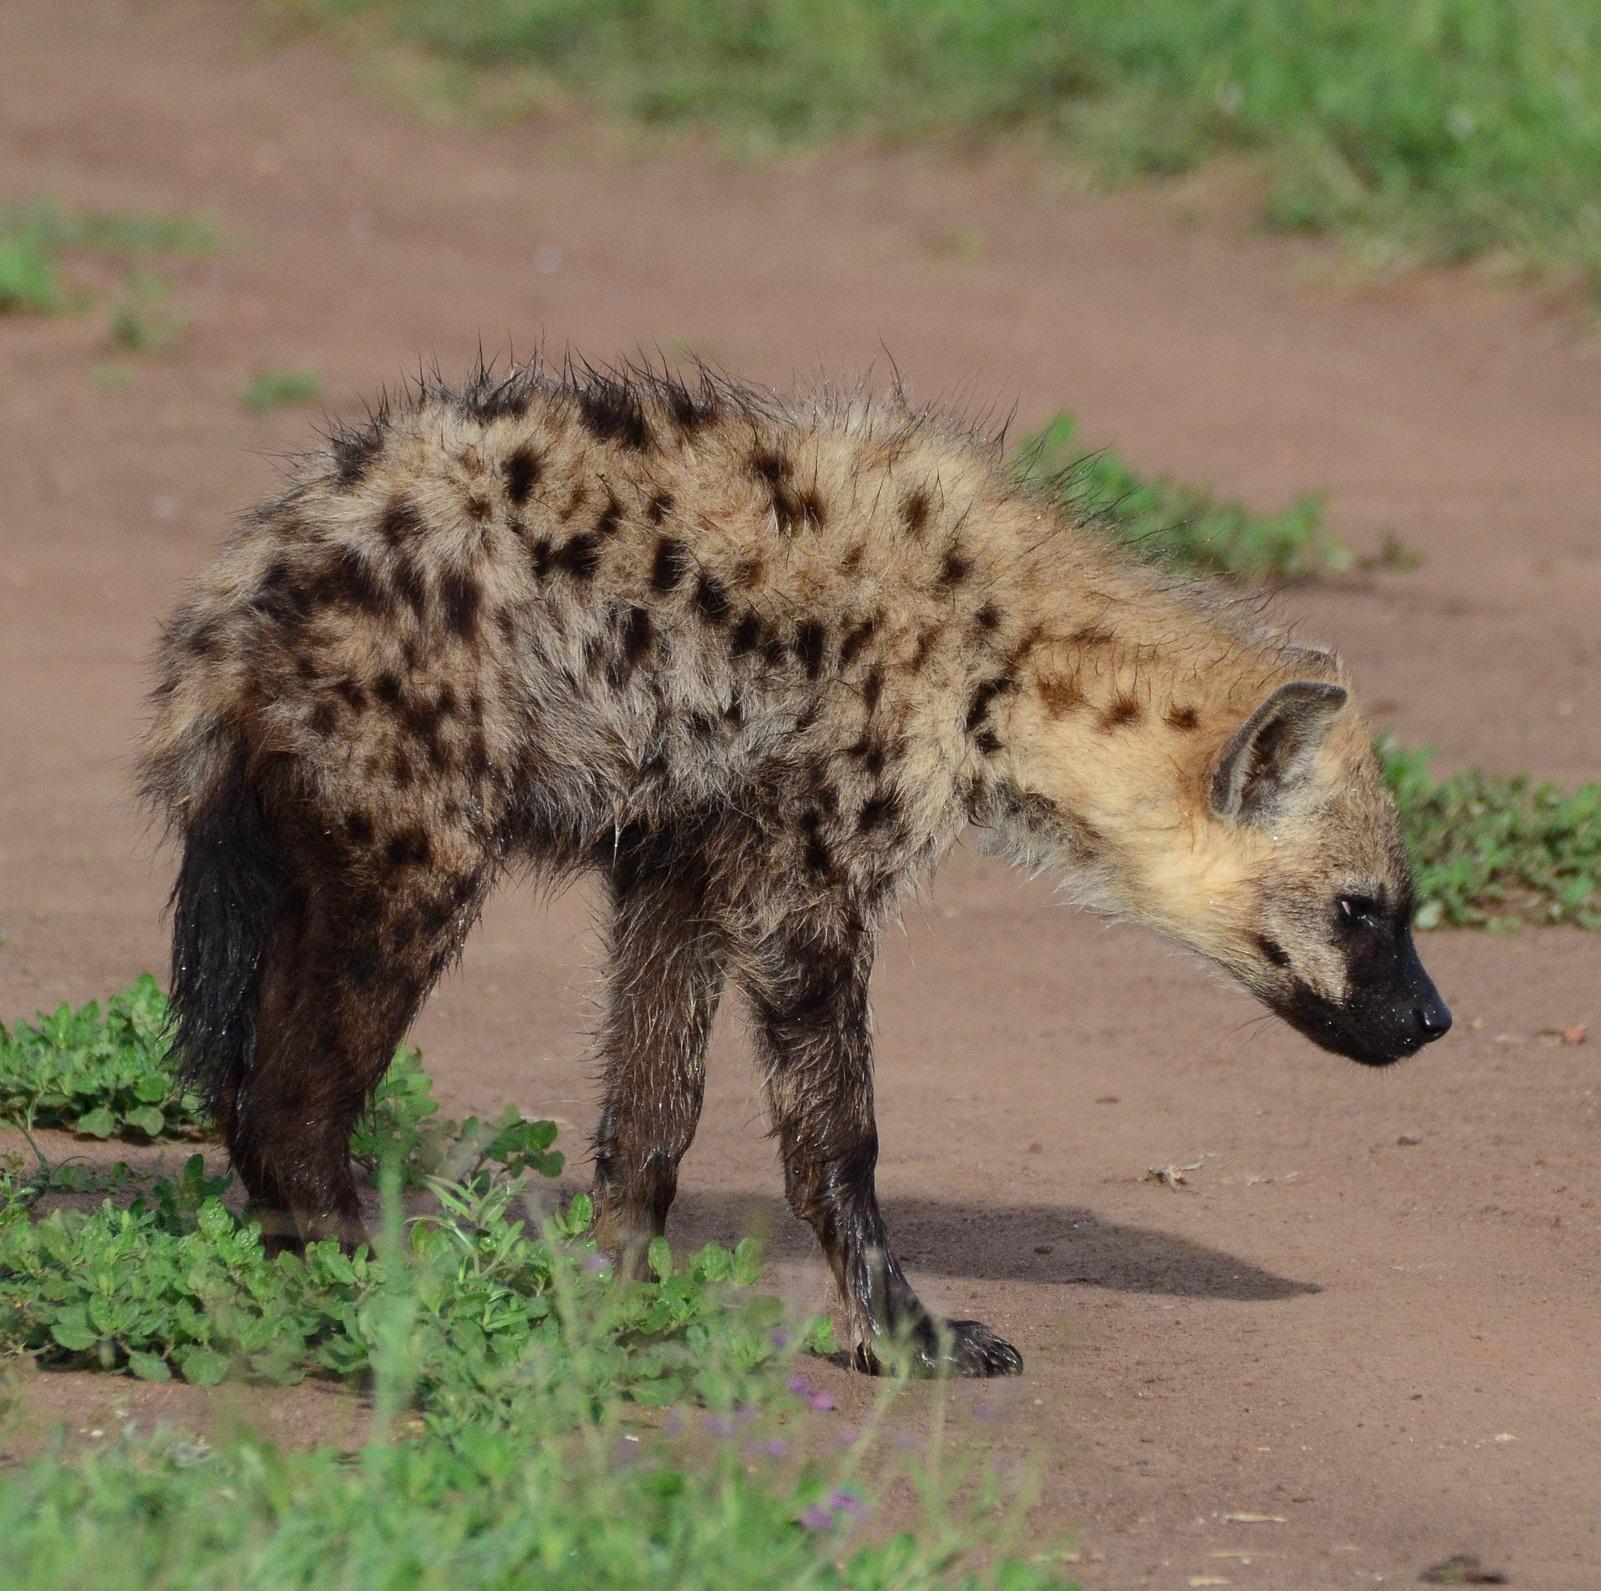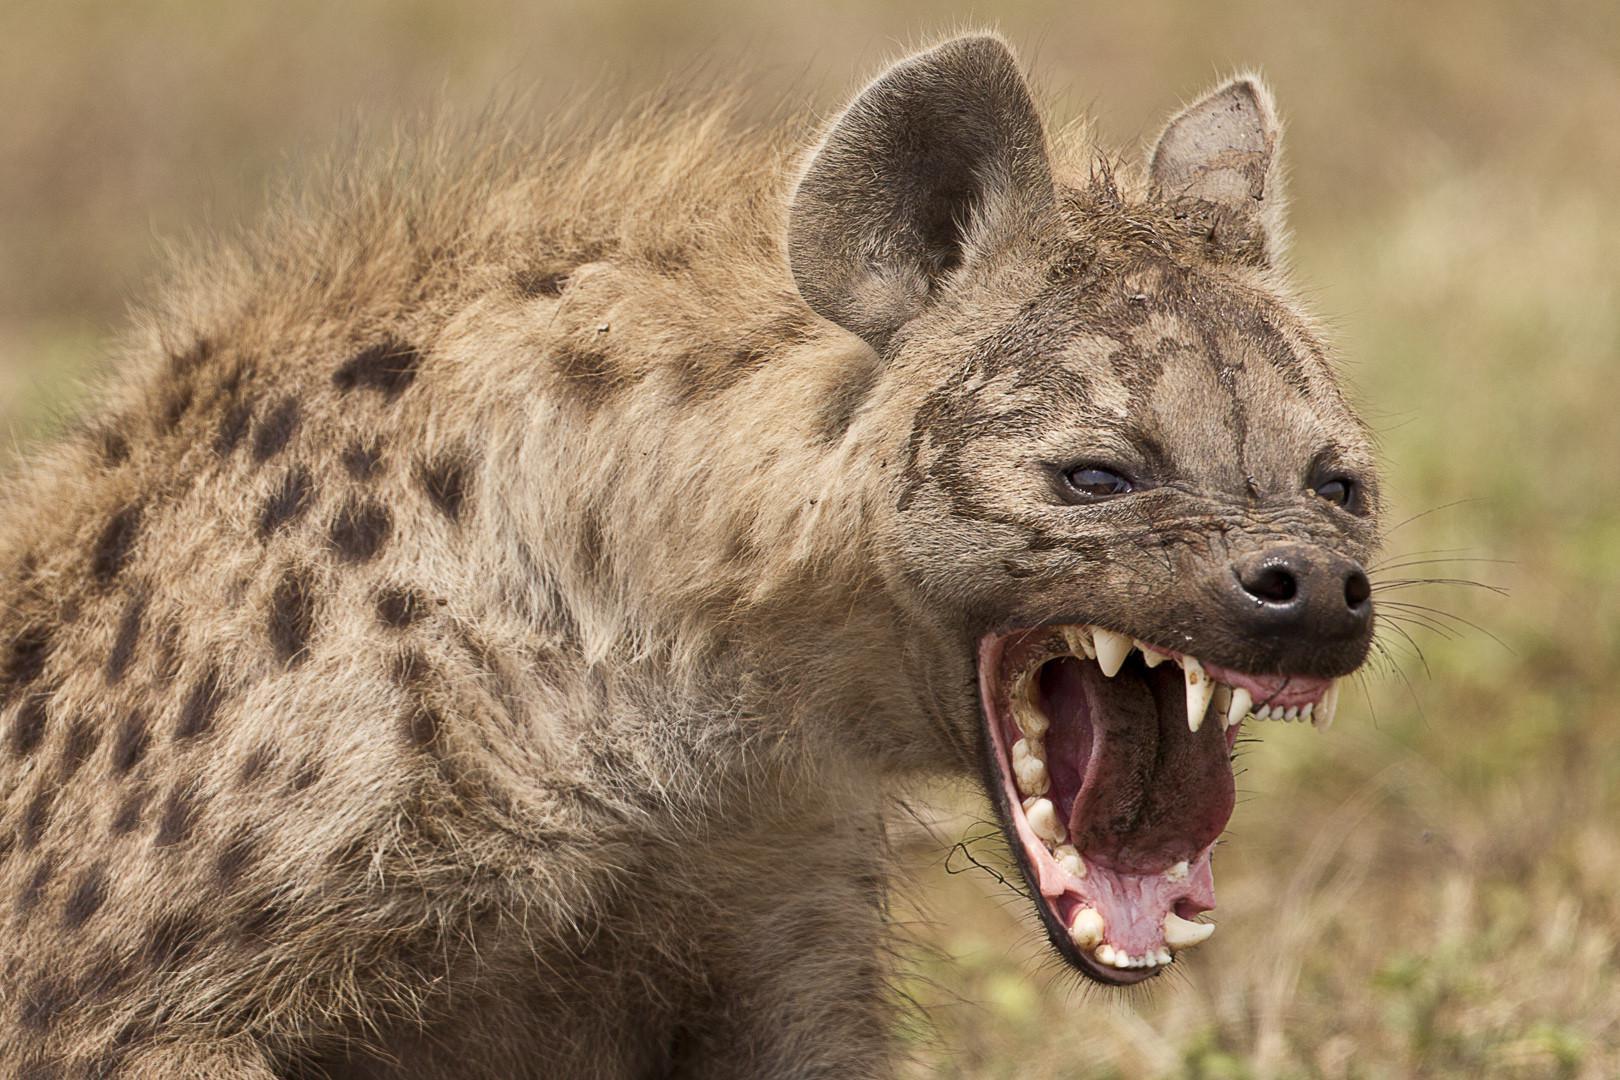The first image is the image on the left, the second image is the image on the right. Considering the images on both sides, is "There is at least three animals total across the images." valid? Answer yes or no. No. 